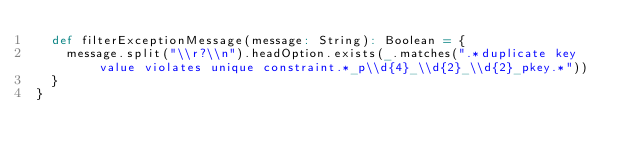Convert code to text. <code><loc_0><loc_0><loc_500><loc_500><_Scala_>  def filterExceptionMessage(message: String): Boolean = {
    message.split("\\r?\\n").headOption.exists(_.matches(".*duplicate key value violates unique constraint.*_p\\d{4}_\\d{2}_\\d{2}_pkey.*"))
  }
}
</code> 